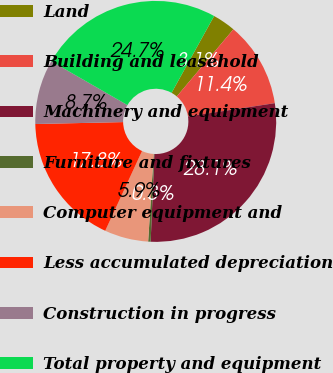Convert chart. <chart><loc_0><loc_0><loc_500><loc_500><pie_chart><fcel>Land<fcel>Building and leasehold<fcel>Machinery and equipment<fcel>Furniture and fixtures<fcel>Computer equipment and<fcel>Less accumulated depreciation<fcel>Construction in progress<fcel>Total property and equipment<nl><fcel>3.1%<fcel>11.43%<fcel>28.09%<fcel>0.33%<fcel>5.88%<fcel>17.77%<fcel>8.66%<fcel>24.74%<nl></chart> 